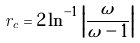Convert formula to latex. <formula><loc_0><loc_0><loc_500><loc_500>r _ { c } = 2 \ln ^ { - 1 } \left | \frac { \omega } { \omega - 1 } \right |</formula> 